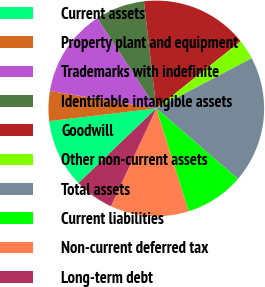Convert chart to OTSL. <chart><loc_0><loc_0><loc_500><loc_500><pie_chart><fcel>Current assets<fcel>Property plant and equipment<fcel>Trademarks with indefinite<fcel>Identifiable intangible assets<fcel>Goodwill<fcel>Other non-current assets<fcel>Total assets<fcel>Current liabilities<fcel>Non-current deferred tax<fcel>Long-term debt<nl><fcel>10.29%<fcel>4.47%<fcel>13.2%<fcel>7.38%<fcel>16.12%<fcel>3.01%<fcel>19.03%<fcel>8.83%<fcel>11.75%<fcel>5.92%<nl></chart> 